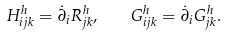Convert formula to latex. <formula><loc_0><loc_0><loc_500><loc_500>H ^ { h } _ { i j k } = \dot { \partial } _ { i } R ^ { h } _ { j k } , \quad G ^ { h } _ { i j k } = \dot { \partial } _ { i } G ^ { h } _ { j k } .</formula> 